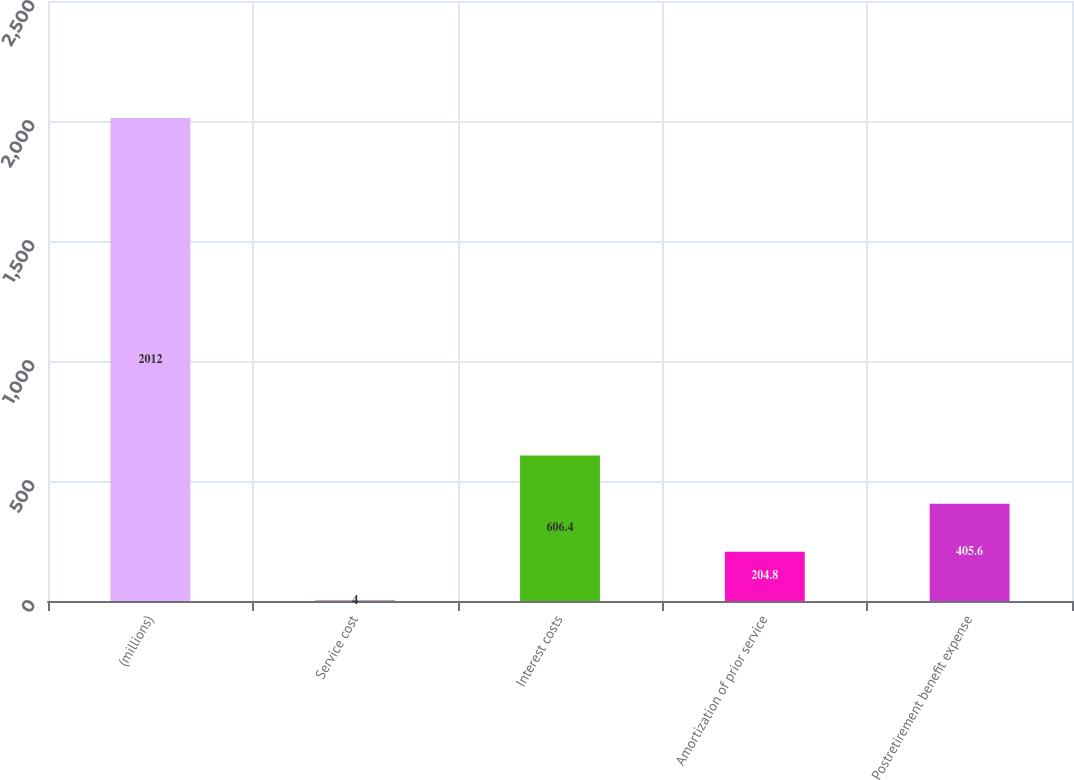Convert chart to OTSL. <chart><loc_0><loc_0><loc_500><loc_500><bar_chart><fcel>(millions)<fcel>Service cost<fcel>Interest costs<fcel>Amortization of prior service<fcel>Postretirement benefit expense<nl><fcel>2012<fcel>4<fcel>606.4<fcel>204.8<fcel>405.6<nl></chart> 